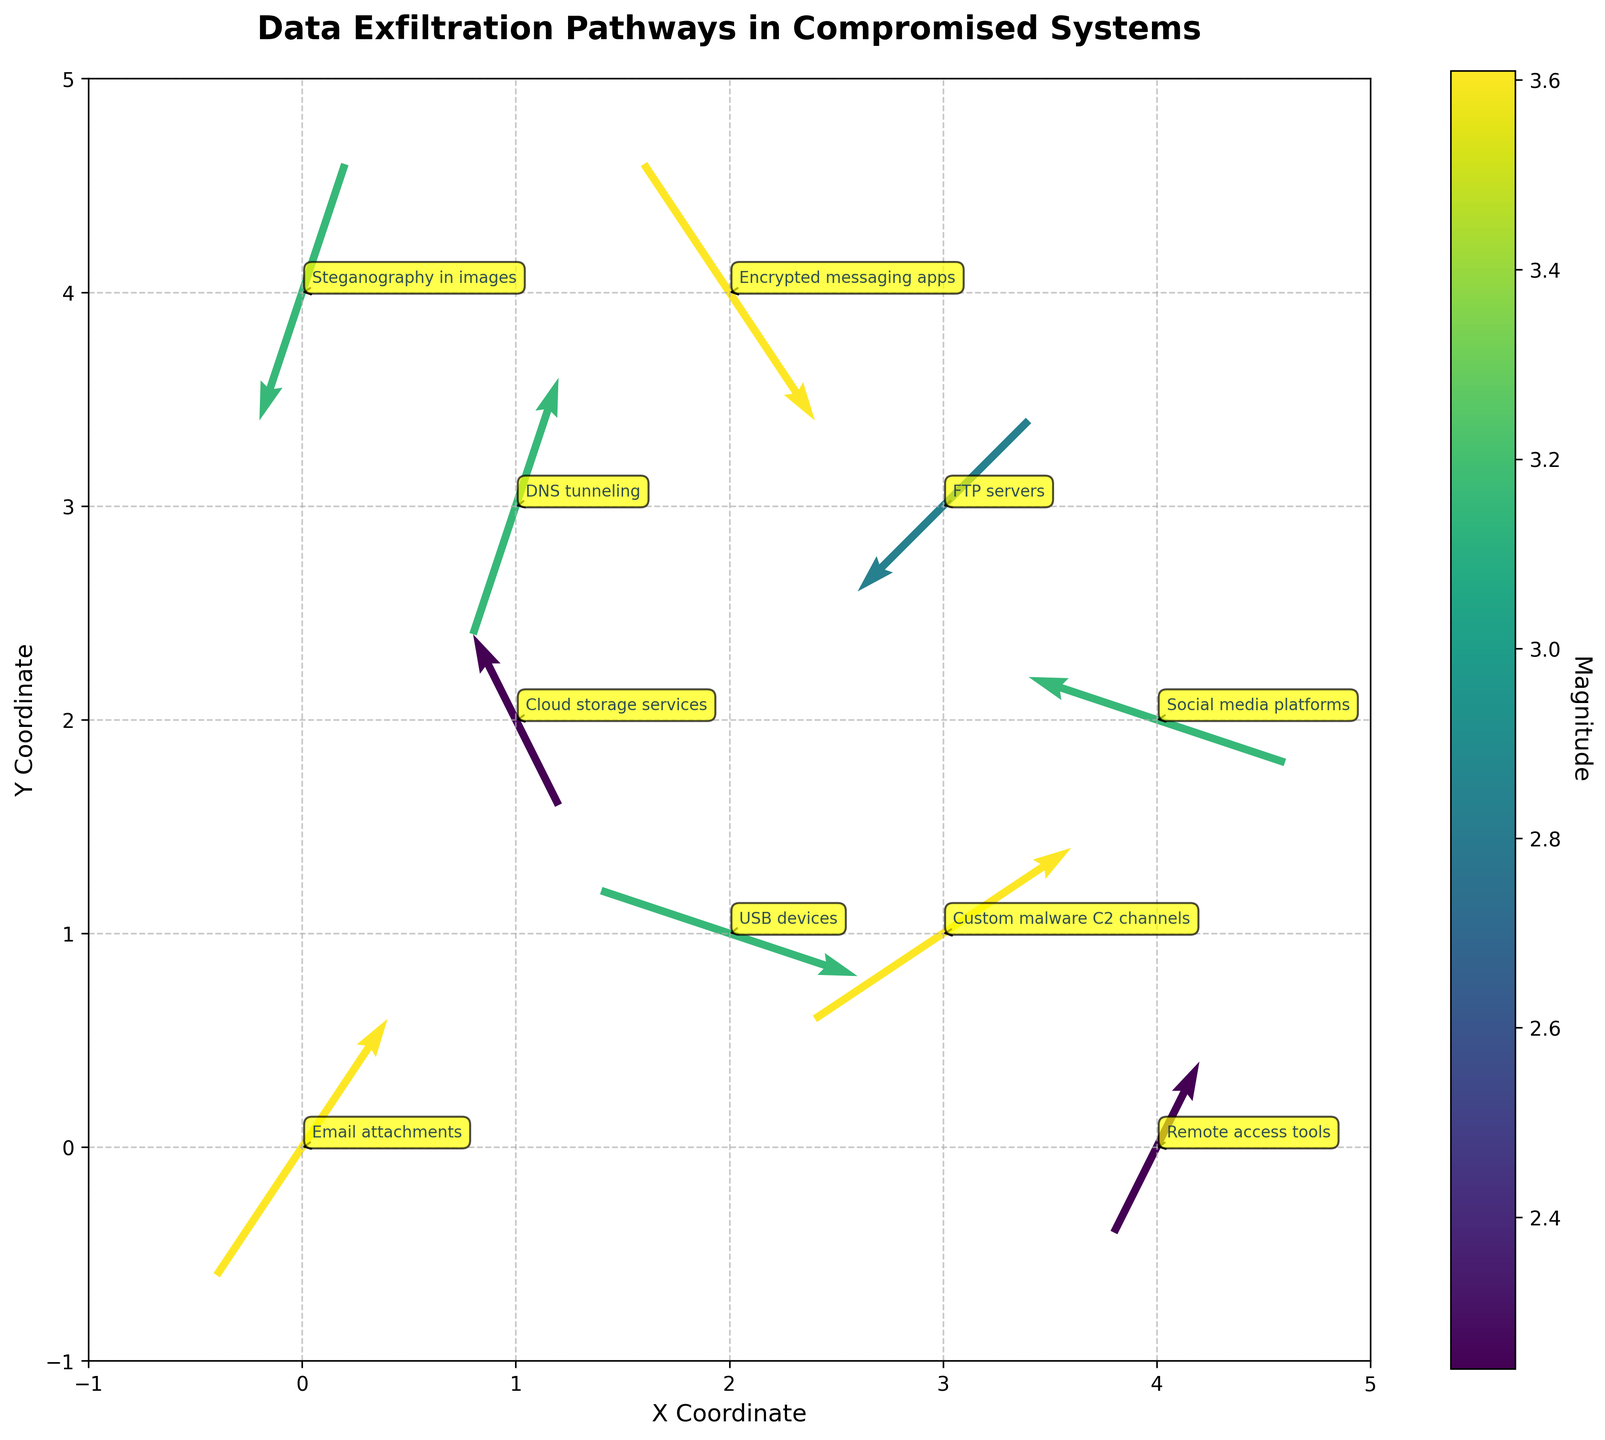What's the title of the plot? The title of the plot is located at the top and provides a summary of what the plot represents. In this case, it reads "Data Exfiltration Pathways in Compromised Systems".
Answer: Data Exfiltration Pathways in Compromised Systems How many data points are shown in the plot? Each quiver (arrow) represents one data point. We can see the number of unique starting points of these arrows. By counting these points, we find there are 10 data points.
Answer: 10 Which data exfiltration method has the highest magnitude? To find this, look at the color and length of the arrows; the color intensity represents the magnitude. By cross-referencing the data table sorted by magnitude in descending order, we see that "Email attachments" and "Encrypted messaging apps" both have the highest magnitude of 3.61.
Answer: Email attachments and Encrypted messaging apps What are the x and y coordinates of the quiver representing DNS tunneling? To find this, look for the label "DNS tunneling" on the plot and note its associated coordinates. The plot shows this label at coordinates (1, 3).
Answer: (1, 3) Which exfiltration method points directly upward, and what is its magnitude? Arrows pointing directly upward have u=0 and v>0. From the data provided, "Remote access tools" with coordinates (4, 0) satisfy these conditions, and its magnitude is 2.24.
Answer: Remote access tools, 2.24 What is the average magnitude of all the data points? To calculate this, sum all the magnitudes and divide by the number of data points. Sum = 3.61 + 2.24 + 3.16 + 2.83 + 3.16 + 3.16 + 3.61 + 2.24 + 3.16 + 3.61 = 30.78. Average = 30.78 / 10 = 3.08.
Answer: 3.08 Which methods show movement to the left (negative x-direction), and what are their magnitudes? Methods moving to the left have u<0. From the data, "Cloud storage services" with magnitude 2.24, "FTP servers" with magnitude 2.83, "Social media platforms" with magnitude 3.16, and "Steganography in images" with magnitude 3.16 move to the left.
Answer: Cloud storage services (2.24), FTP servers (2.83), Social media platforms (3.16), Steganography in images (3.16) Comparing 'Email attachments' and 'FTP servers', which one has a greater magnitude? By comparing the magnitude values, 'Email attachments' has a magnitude of 3.61, while 'FTP servers' have a magnitude of 2.83. Therefore, 'Email attachments' has a greater magnitude.
Answer: Email attachments 